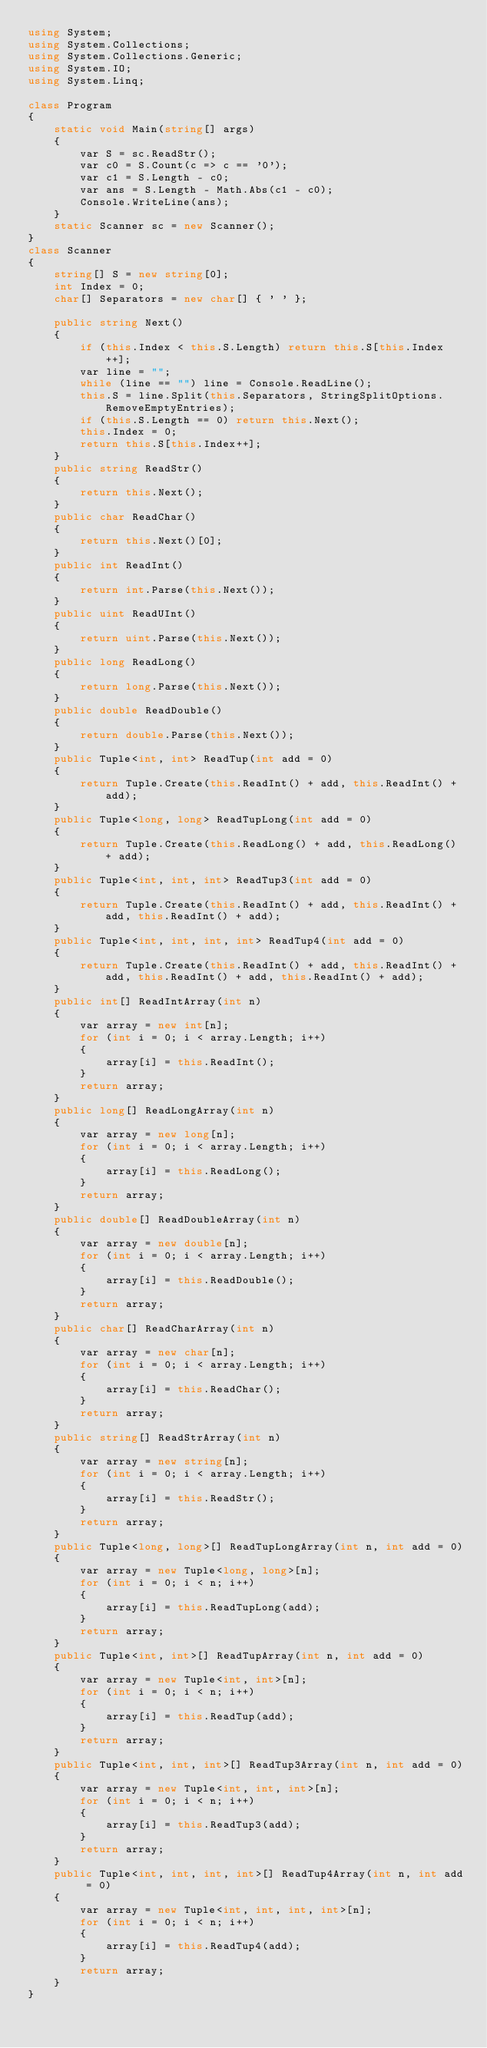Convert code to text. <code><loc_0><loc_0><loc_500><loc_500><_C#_>using System;
using System.Collections;
using System.Collections.Generic;
using System.IO;
using System.Linq;

class Program
{
    static void Main(string[] args)
    {
        var S = sc.ReadStr();
        var c0 = S.Count(c => c == '0');
        var c1 = S.Length - c0;
        var ans = S.Length - Math.Abs(c1 - c0);
        Console.WriteLine(ans);
    }
    static Scanner sc = new Scanner();
}
class Scanner
{
    string[] S = new string[0];
    int Index = 0;
    char[] Separators = new char[] { ' ' };

    public string Next()
    {
        if (this.Index < this.S.Length) return this.S[this.Index++];
        var line = "";
        while (line == "") line = Console.ReadLine();
        this.S = line.Split(this.Separators, StringSplitOptions.RemoveEmptyEntries);
        if (this.S.Length == 0) return this.Next();
        this.Index = 0;
        return this.S[this.Index++];
    }
    public string ReadStr()
    {
        return this.Next();
    }
    public char ReadChar()
    {
        return this.Next()[0];
    }
    public int ReadInt()
    {
        return int.Parse(this.Next());
    }
    public uint ReadUInt()
    {
        return uint.Parse(this.Next());
    }
    public long ReadLong()
    {
        return long.Parse(this.Next());
    }
    public double ReadDouble()
    {
        return double.Parse(this.Next());
    }
    public Tuple<int, int> ReadTup(int add = 0)
    {
        return Tuple.Create(this.ReadInt() + add, this.ReadInt() + add);
    }
    public Tuple<long, long> ReadTupLong(int add = 0)
    {
        return Tuple.Create(this.ReadLong() + add, this.ReadLong() + add);
    }
    public Tuple<int, int, int> ReadTup3(int add = 0)
    {
        return Tuple.Create(this.ReadInt() + add, this.ReadInt() + add, this.ReadInt() + add);
    }
    public Tuple<int, int, int, int> ReadTup4(int add = 0)
    {
        return Tuple.Create(this.ReadInt() + add, this.ReadInt() + add, this.ReadInt() + add, this.ReadInt() + add);
    }
    public int[] ReadIntArray(int n)
    {
        var array = new int[n];
        for (int i = 0; i < array.Length; i++)
        {
            array[i] = this.ReadInt();
        }
        return array;
    }
    public long[] ReadLongArray(int n)
    {
        var array = new long[n];
        for (int i = 0; i < array.Length; i++)
        {
            array[i] = this.ReadLong();
        }
        return array;
    }
    public double[] ReadDoubleArray(int n)
    {
        var array = new double[n];
        for (int i = 0; i < array.Length; i++)
        {
            array[i] = this.ReadDouble();
        }
        return array;
    }
    public char[] ReadCharArray(int n)
    {
        var array = new char[n];
        for (int i = 0; i < array.Length; i++)
        {
            array[i] = this.ReadChar();
        }
        return array;
    }
    public string[] ReadStrArray(int n)
    {
        var array = new string[n];
        for (int i = 0; i < array.Length; i++)
        {
            array[i] = this.ReadStr();
        }
        return array;
    }
    public Tuple<long, long>[] ReadTupLongArray(int n, int add = 0)
    {
        var array = new Tuple<long, long>[n];
        for (int i = 0; i < n; i++)
        {
            array[i] = this.ReadTupLong(add);
        }
        return array;
    }
    public Tuple<int, int>[] ReadTupArray(int n, int add = 0)
    {
        var array = new Tuple<int, int>[n];
        for (int i = 0; i < n; i++)
        {
            array[i] = this.ReadTup(add);
        }
        return array;
    }
    public Tuple<int, int, int>[] ReadTup3Array(int n, int add = 0)
    {
        var array = new Tuple<int, int, int>[n];
        for (int i = 0; i < n; i++)
        {
            array[i] = this.ReadTup3(add);
        }
        return array;
    }
    public Tuple<int, int, int, int>[] ReadTup4Array(int n, int add = 0)
    {
        var array = new Tuple<int, int, int, int>[n];
        for (int i = 0; i < n; i++)
        {
            array[i] = this.ReadTup4(add);
        }
        return array;
    }
}
</code> 